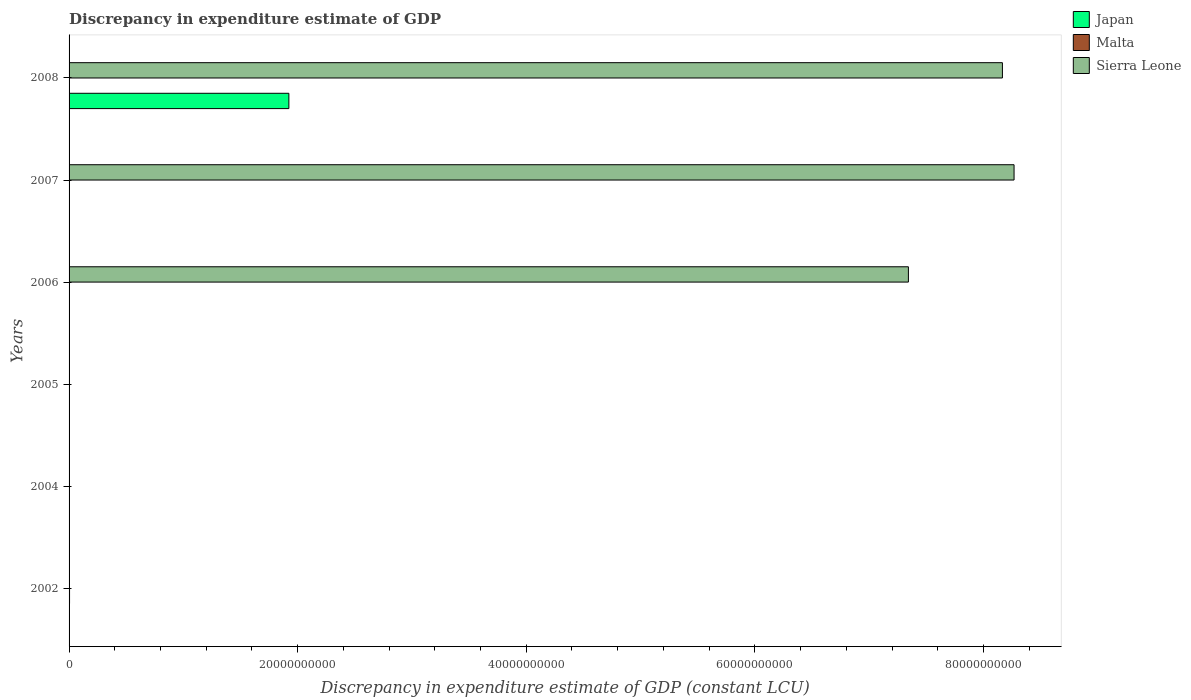Are the number of bars per tick equal to the number of legend labels?
Make the answer very short. No. How many bars are there on the 2nd tick from the bottom?
Give a very brief answer. 0. What is the label of the 6th group of bars from the top?
Your answer should be compact. 2002. In how many cases, is the number of bars for a given year not equal to the number of legend labels?
Keep it short and to the point. 6. Across all years, what is the maximum discrepancy in expenditure estimate of GDP in Japan?
Make the answer very short. 1.92e+1. Across all years, what is the minimum discrepancy in expenditure estimate of GDP in Japan?
Your answer should be compact. 0. What is the total discrepancy in expenditure estimate of GDP in Japan in the graph?
Give a very brief answer. 1.92e+1. What is the difference between the discrepancy in expenditure estimate of GDP in Sierra Leone in 2007 and that in 2008?
Offer a terse response. 1.02e+09. What is the difference between the discrepancy in expenditure estimate of GDP in Sierra Leone in 2006 and the discrepancy in expenditure estimate of GDP in Japan in 2008?
Ensure brevity in your answer.  5.42e+1. What is the average discrepancy in expenditure estimate of GDP in Japan per year?
Offer a terse response. 3.21e+09. In the year 2008, what is the difference between the discrepancy in expenditure estimate of GDP in Sierra Leone and discrepancy in expenditure estimate of GDP in Japan?
Your answer should be compact. 6.24e+1. In how many years, is the discrepancy in expenditure estimate of GDP in Malta greater than 56000000000 LCU?
Your response must be concise. 0. What is the ratio of the discrepancy in expenditure estimate of GDP in Sierra Leone in 2002 to that in 2007?
Offer a terse response. 7.257218201582226e-5. Is the discrepancy in expenditure estimate of GDP in Malta in 2002 less than that in 2005?
Make the answer very short. No. What is the difference between the highest and the lowest discrepancy in expenditure estimate of GDP in Malta?
Give a very brief answer. 4.13e+07. Is the sum of the discrepancy in expenditure estimate of GDP in Sierra Leone in 2002 and 2006 greater than the maximum discrepancy in expenditure estimate of GDP in Japan across all years?
Your answer should be compact. Yes. What is the difference between two consecutive major ticks on the X-axis?
Provide a succinct answer. 2.00e+1. Are the values on the major ticks of X-axis written in scientific E-notation?
Provide a succinct answer. No. Does the graph contain any zero values?
Provide a short and direct response. Yes. How are the legend labels stacked?
Offer a terse response. Vertical. What is the title of the graph?
Offer a terse response. Discrepancy in expenditure estimate of GDP. Does "Germany" appear as one of the legend labels in the graph?
Offer a very short reply. No. What is the label or title of the X-axis?
Your answer should be compact. Discrepancy in expenditure estimate of GDP (constant LCU). What is the Discrepancy in expenditure estimate of GDP (constant LCU) of Malta in 2002?
Make the answer very short. 4.13e+07. What is the Discrepancy in expenditure estimate of GDP (constant LCU) in Japan in 2004?
Provide a succinct answer. 0. What is the Discrepancy in expenditure estimate of GDP (constant LCU) in Malta in 2004?
Provide a succinct answer. 0. What is the Discrepancy in expenditure estimate of GDP (constant LCU) of Japan in 2005?
Make the answer very short. 0. What is the Discrepancy in expenditure estimate of GDP (constant LCU) in Sierra Leone in 2005?
Keep it short and to the point. 3.00e+06. What is the Discrepancy in expenditure estimate of GDP (constant LCU) in Sierra Leone in 2006?
Make the answer very short. 7.34e+1. What is the Discrepancy in expenditure estimate of GDP (constant LCU) in Sierra Leone in 2007?
Offer a very short reply. 8.27e+1. What is the Discrepancy in expenditure estimate of GDP (constant LCU) of Japan in 2008?
Provide a succinct answer. 1.92e+1. What is the Discrepancy in expenditure estimate of GDP (constant LCU) of Malta in 2008?
Offer a very short reply. 0. What is the Discrepancy in expenditure estimate of GDP (constant LCU) in Sierra Leone in 2008?
Your answer should be compact. 8.17e+1. Across all years, what is the maximum Discrepancy in expenditure estimate of GDP (constant LCU) of Japan?
Offer a very short reply. 1.92e+1. Across all years, what is the maximum Discrepancy in expenditure estimate of GDP (constant LCU) of Malta?
Your answer should be compact. 4.13e+07. Across all years, what is the maximum Discrepancy in expenditure estimate of GDP (constant LCU) in Sierra Leone?
Your answer should be very brief. 8.27e+1. Across all years, what is the minimum Discrepancy in expenditure estimate of GDP (constant LCU) of Malta?
Make the answer very short. 0. What is the total Discrepancy in expenditure estimate of GDP (constant LCU) of Japan in the graph?
Keep it short and to the point. 1.92e+1. What is the total Discrepancy in expenditure estimate of GDP (constant LCU) in Malta in the graph?
Give a very brief answer. 4.14e+07. What is the total Discrepancy in expenditure estimate of GDP (constant LCU) of Sierra Leone in the graph?
Your response must be concise. 2.38e+11. What is the difference between the Discrepancy in expenditure estimate of GDP (constant LCU) of Malta in 2002 and that in 2005?
Make the answer very short. 4.12e+07. What is the difference between the Discrepancy in expenditure estimate of GDP (constant LCU) of Sierra Leone in 2002 and that in 2006?
Provide a short and direct response. -7.34e+1. What is the difference between the Discrepancy in expenditure estimate of GDP (constant LCU) of Sierra Leone in 2002 and that in 2007?
Offer a terse response. -8.27e+1. What is the difference between the Discrepancy in expenditure estimate of GDP (constant LCU) in Sierra Leone in 2002 and that in 2008?
Your answer should be very brief. -8.17e+1. What is the difference between the Discrepancy in expenditure estimate of GDP (constant LCU) in Sierra Leone in 2005 and that in 2006?
Ensure brevity in your answer.  -7.34e+1. What is the difference between the Discrepancy in expenditure estimate of GDP (constant LCU) of Sierra Leone in 2005 and that in 2007?
Give a very brief answer. -8.27e+1. What is the difference between the Discrepancy in expenditure estimate of GDP (constant LCU) in Sierra Leone in 2005 and that in 2008?
Provide a succinct answer. -8.17e+1. What is the difference between the Discrepancy in expenditure estimate of GDP (constant LCU) of Sierra Leone in 2006 and that in 2007?
Offer a terse response. -9.24e+09. What is the difference between the Discrepancy in expenditure estimate of GDP (constant LCU) in Sierra Leone in 2006 and that in 2008?
Provide a succinct answer. -8.23e+09. What is the difference between the Discrepancy in expenditure estimate of GDP (constant LCU) in Sierra Leone in 2007 and that in 2008?
Your answer should be compact. 1.02e+09. What is the difference between the Discrepancy in expenditure estimate of GDP (constant LCU) in Malta in 2002 and the Discrepancy in expenditure estimate of GDP (constant LCU) in Sierra Leone in 2005?
Make the answer very short. 3.83e+07. What is the difference between the Discrepancy in expenditure estimate of GDP (constant LCU) in Malta in 2002 and the Discrepancy in expenditure estimate of GDP (constant LCU) in Sierra Leone in 2006?
Keep it short and to the point. -7.34e+1. What is the difference between the Discrepancy in expenditure estimate of GDP (constant LCU) in Malta in 2002 and the Discrepancy in expenditure estimate of GDP (constant LCU) in Sierra Leone in 2007?
Make the answer very short. -8.26e+1. What is the difference between the Discrepancy in expenditure estimate of GDP (constant LCU) in Malta in 2002 and the Discrepancy in expenditure estimate of GDP (constant LCU) in Sierra Leone in 2008?
Provide a succinct answer. -8.16e+1. What is the difference between the Discrepancy in expenditure estimate of GDP (constant LCU) of Malta in 2005 and the Discrepancy in expenditure estimate of GDP (constant LCU) of Sierra Leone in 2006?
Provide a short and direct response. -7.34e+1. What is the difference between the Discrepancy in expenditure estimate of GDP (constant LCU) in Malta in 2005 and the Discrepancy in expenditure estimate of GDP (constant LCU) in Sierra Leone in 2007?
Make the answer very short. -8.27e+1. What is the difference between the Discrepancy in expenditure estimate of GDP (constant LCU) in Malta in 2005 and the Discrepancy in expenditure estimate of GDP (constant LCU) in Sierra Leone in 2008?
Provide a succinct answer. -8.17e+1. What is the average Discrepancy in expenditure estimate of GDP (constant LCU) of Japan per year?
Make the answer very short. 3.21e+09. What is the average Discrepancy in expenditure estimate of GDP (constant LCU) of Malta per year?
Keep it short and to the point. 6.90e+06. What is the average Discrepancy in expenditure estimate of GDP (constant LCU) of Sierra Leone per year?
Keep it short and to the point. 3.96e+1. In the year 2002, what is the difference between the Discrepancy in expenditure estimate of GDP (constant LCU) of Malta and Discrepancy in expenditure estimate of GDP (constant LCU) of Sierra Leone?
Your answer should be very brief. 3.53e+07. In the year 2005, what is the difference between the Discrepancy in expenditure estimate of GDP (constant LCU) of Malta and Discrepancy in expenditure estimate of GDP (constant LCU) of Sierra Leone?
Offer a very short reply. -2.90e+06. In the year 2008, what is the difference between the Discrepancy in expenditure estimate of GDP (constant LCU) in Japan and Discrepancy in expenditure estimate of GDP (constant LCU) in Sierra Leone?
Ensure brevity in your answer.  -6.24e+1. What is the ratio of the Discrepancy in expenditure estimate of GDP (constant LCU) in Malta in 2002 to that in 2005?
Ensure brevity in your answer.  412.83. What is the ratio of the Discrepancy in expenditure estimate of GDP (constant LCU) in Sierra Leone in 2002 to that in 2005?
Your answer should be very brief. 2. What is the ratio of the Discrepancy in expenditure estimate of GDP (constant LCU) in Sierra Leone in 2002 to that in 2006?
Your response must be concise. 0. What is the ratio of the Discrepancy in expenditure estimate of GDP (constant LCU) of Sierra Leone in 2002 to that in 2007?
Provide a short and direct response. 0. What is the ratio of the Discrepancy in expenditure estimate of GDP (constant LCU) of Sierra Leone in 2002 to that in 2008?
Your response must be concise. 0. What is the ratio of the Discrepancy in expenditure estimate of GDP (constant LCU) of Sierra Leone in 2005 to that in 2006?
Provide a succinct answer. 0. What is the ratio of the Discrepancy in expenditure estimate of GDP (constant LCU) in Sierra Leone in 2005 to that in 2007?
Provide a short and direct response. 0. What is the ratio of the Discrepancy in expenditure estimate of GDP (constant LCU) of Sierra Leone in 2006 to that in 2007?
Offer a terse response. 0.89. What is the ratio of the Discrepancy in expenditure estimate of GDP (constant LCU) in Sierra Leone in 2006 to that in 2008?
Give a very brief answer. 0.9. What is the ratio of the Discrepancy in expenditure estimate of GDP (constant LCU) of Sierra Leone in 2007 to that in 2008?
Give a very brief answer. 1.01. What is the difference between the highest and the second highest Discrepancy in expenditure estimate of GDP (constant LCU) in Sierra Leone?
Your answer should be compact. 1.02e+09. What is the difference between the highest and the lowest Discrepancy in expenditure estimate of GDP (constant LCU) of Japan?
Offer a terse response. 1.92e+1. What is the difference between the highest and the lowest Discrepancy in expenditure estimate of GDP (constant LCU) in Malta?
Your response must be concise. 4.13e+07. What is the difference between the highest and the lowest Discrepancy in expenditure estimate of GDP (constant LCU) of Sierra Leone?
Give a very brief answer. 8.27e+1. 